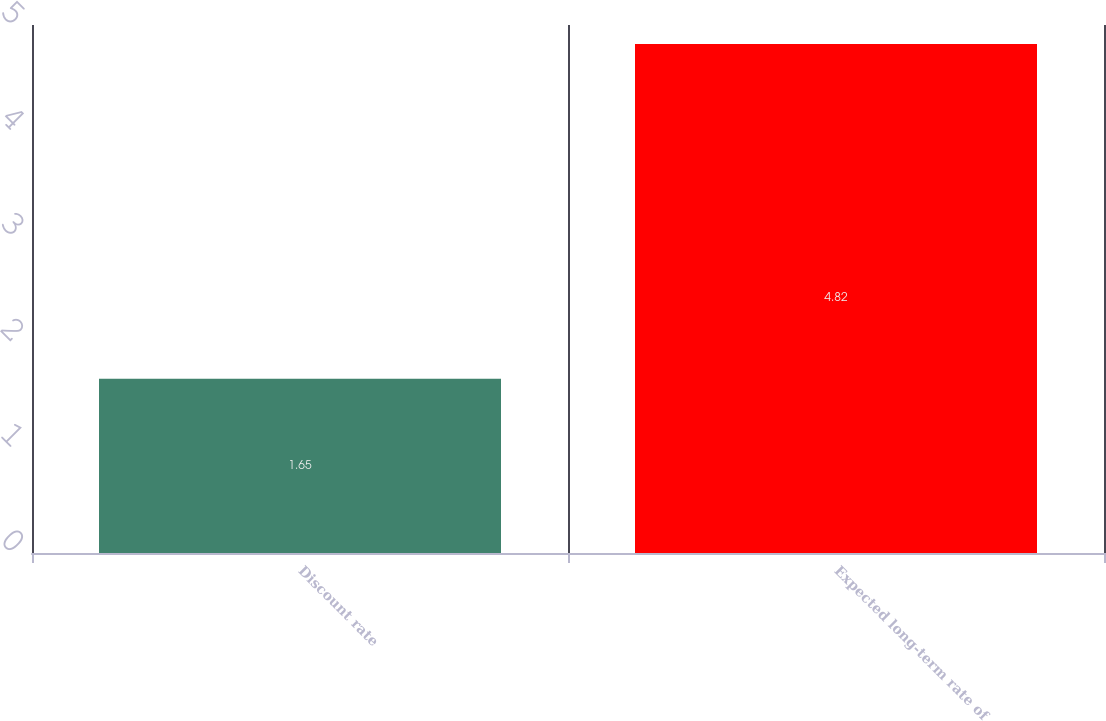Convert chart. <chart><loc_0><loc_0><loc_500><loc_500><bar_chart><fcel>Discount rate<fcel>Expected long-term rate of<nl><fcel>1.65<fcel>4.82<nl></chart> 